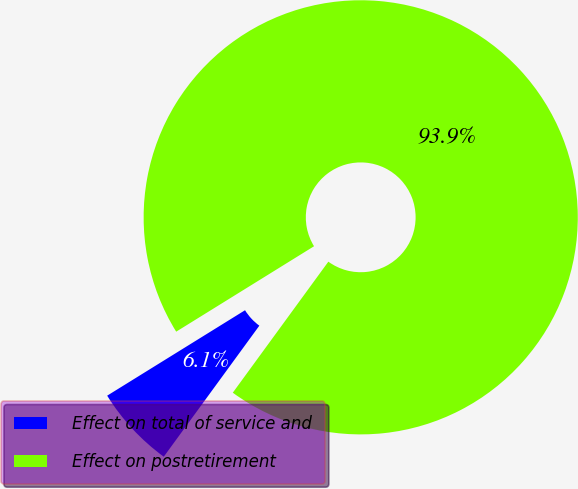Convert chart. <chart><loc_0><loc_0><loc_500><loc_500><pie_chart><fcel>Effect on total of service and<fcel>Effect on postretirement<nl><fcel>6.14%<fcel>93.86%<nl></chart> 